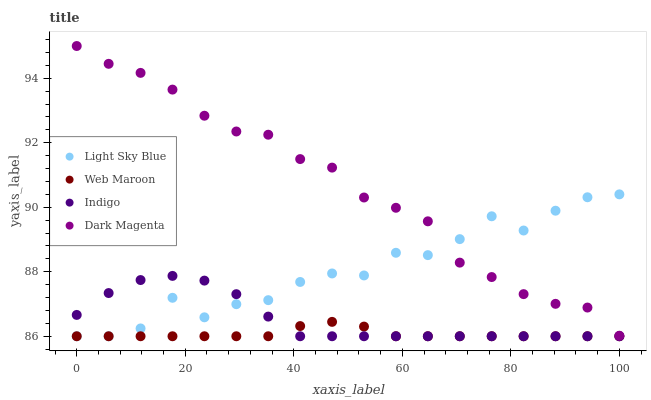Does Web Maroon have the minimum area under the curve?
Answer yes or no. Yes. Does Dark Magenta have the maximum area under the curve?
Answer yes or no. Yes. Does Light Sky Blue have the minimum area under the curve?
Answer yes or no. No. Does Light Sky Blue have the maximum area under the curve?
Answer yes or no. No. Is Web Maroon the smoothest?
Answer yes or no. Yes. Is Light Sky Blue the roughest?
Answer yes or no. Yes. Is Light Sky Blue the smoothest?
Answer yes or no. No. Is Web Maroon the roughest?
Answer yes or no. No. Does Indigo have the lowest value?
Answer yes or no. Yes. Does Dark Magenta have the lowest value?
Answer yes or no. No. Does Dark Magenta have the highest value?
Answer yes or no. Yes. Does Light Sky Blue have the highest value?
Answer yes or no. No. Is Indigo less than Dark Magenta?
Answer yes or no. Yes. Is Dark Magenta greater than Indigo?
Answer yes or no. Yes. Does Light Sky Blue intersect Web Maroon?
Answer yes or no. Yes. Is Light Sky Blue less than Web Maroon?
Answer yes or no. No. Is Light Sky Blue greater than Web Maroon?
Answer yes or no. No. Does Indigo intersect Dark Magenta?
Answer yes or no. No. 